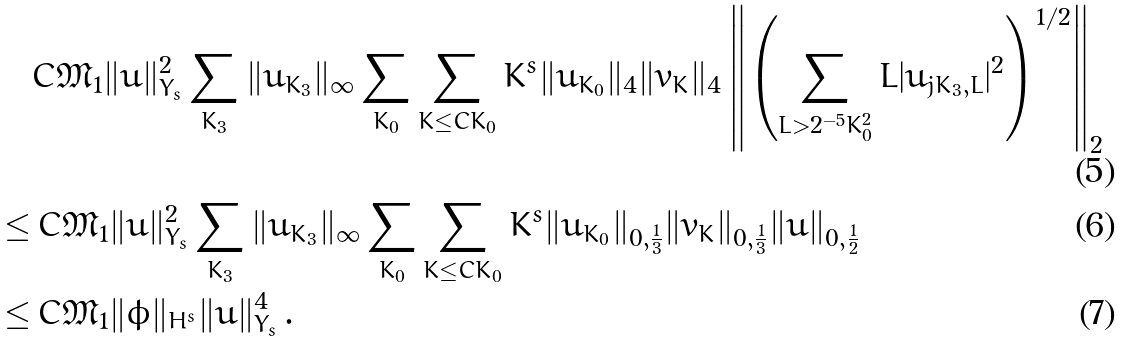Convert formula to latex. <formula><loc_0><loc_0><loc_500><loc_500>& C { \mathfrak M } _ { 1 } \| u \| _ { Y _ { s } } ^ { 2 } \sum _ { K _ { 3 } } \| u _ { K _ { 3 } } \| _ { \infty } \sum _ { K _ { 0 } } \sum _ { K \leq C K _ { 0 } } K ^ { s } \| u _ { K _ { 0 } } \| _ { 4 } \| v _ { K } \| _ { 4 } \left \| \left ( \sum _ { L > 2 ^ { - 5 } K _ { 0 } ^ { 2 } } L | u _ { j K _ { 3 } , L } | ^ { 2 } \right ) ^ { 1 / 2 } \right \| _ { 2 } \\ \leq & \, C { \mathfrak M } _ { 1 } \| u \| _ { Y _ { s } } ^ { 2 } \sum _ { K _ { 3 } } \| u _ { K _ { 3 } } \| _ { \infty } \sum _ { K _ { 0 } } \sum _ { K \leq C K _ { 0 } } K ^ { s } \| u _ { K _ { 0 } } \| _ { 0 , \frac { 1 } { 3 } } \| v _ { K } \| _ { 0 , \frac { 1 } { 3 } } \| u \| _ { 0 , \frac { 1 } { 2 } } \\ \leq & \, C { \mathfrak M } _ { 1 } \| \phi \| _ { H ^ { s } } \| u \| _ { Y _ { s } } ^ { 4 } \, .</formula> 